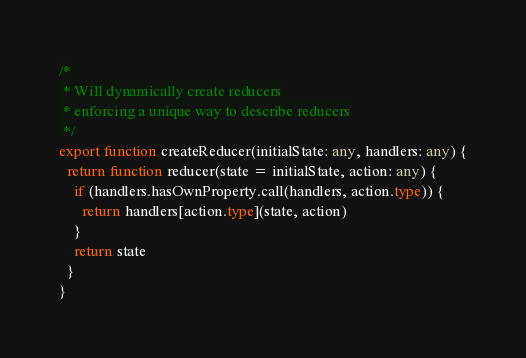Convert code to text. <code><loc_0><loc_0><loc_500><loc_500><_TypeScript_>/*
 * Will dynamically create reducers
 * enforcing a unique way to describe reducers
 */
export function createReducer(initialState: any, handlers: any) {
  return function reducer(state = initialState, action: any) {
    if (handlers.hasOwnProperty.call(handlers, action.type)) {
      return handlers[action.type](state, action)
    }
    return state
  }
}
</code> 